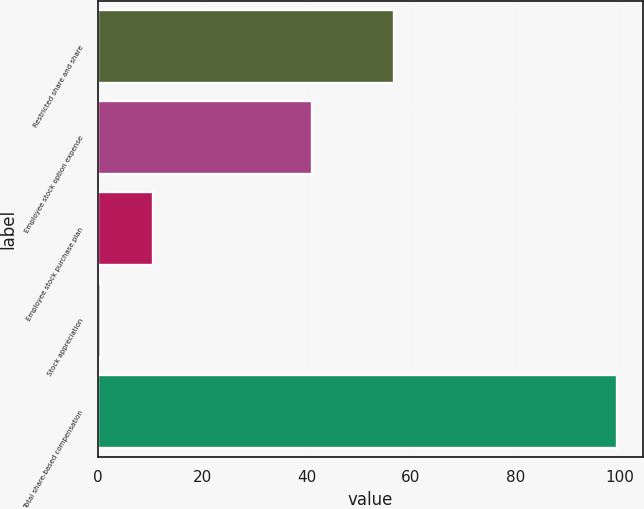Convert chart. <chart><loc_0><loc_0><loc_500><loc_500><bar_chart><fcel>Restricted share and share<fcel>Employee stock option expense<fcel>Employee stock purchase plan<fcel>Stock appreciation<fcel>Total share-based compensation<nl><fcel>56.8<fcel>41<fcel>10.49<fcel>0.6<fcel>99.5<nl></chart> 